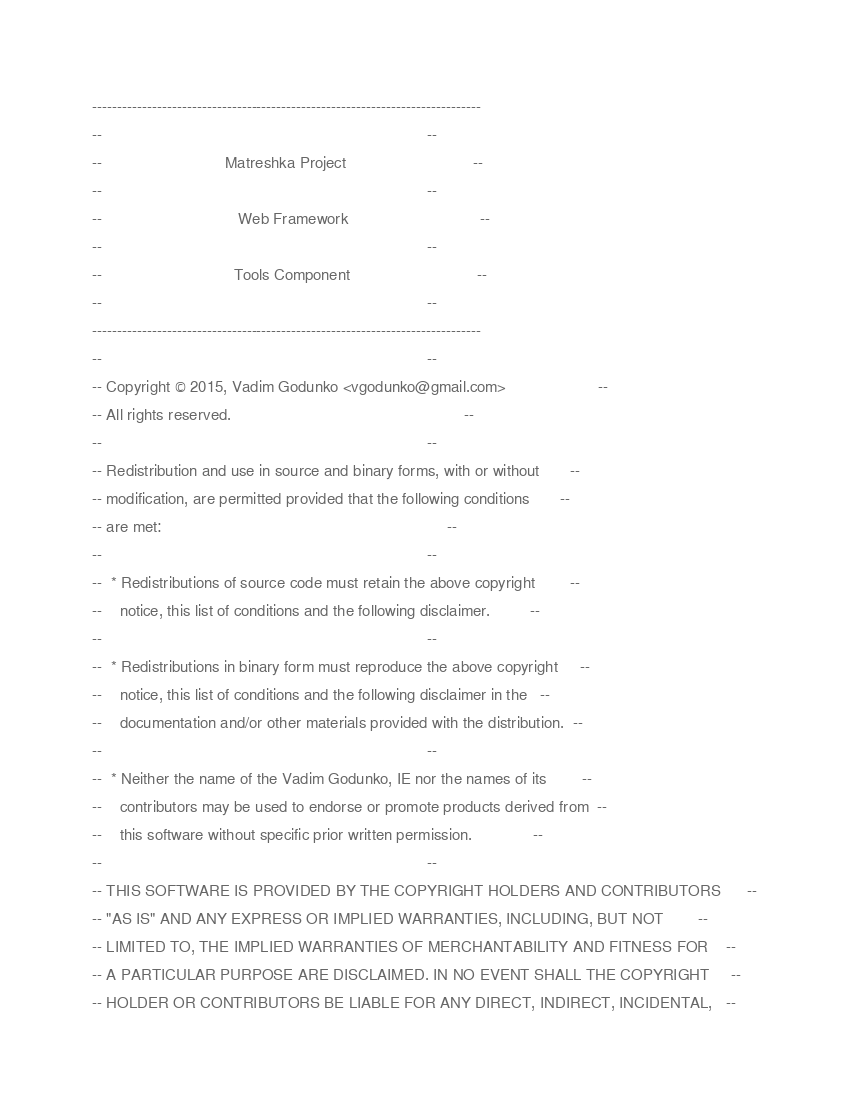Convert code to text. <code><loc_0><loc_0><loc_500><loc_500><_Ada_>------------------------------------------------------------------------------
--                                                                          --
--                            Matreshka Project                             --
--                                                                          --
--                               Web Framework                              --
--                                                                          --
--                              Tools Component                             --
--                                                                          --
------------------------------------------------------------------------------
--                                                                          --
-- Copyright © 2015, Vadim Godunko <vgodunko@gmail.com>                     --
-- All rights reserved.                                                     --
--                                                                          --
-- Redistribution and use in source and binary forms, with or without       --
-- modification, are permitted provided that the following conditions       --
-- are met:                                                                 --
--                                                                          --
--  * Redistributions of source code must retain the above copyright        --
--    notice, this list of conditions and the following disclaimer.         --
--                                                                          --
--  * Redistributions in binary form must reproduce the above copyright     --
--    notice, this list of conditions and the following disclaimer in the   --
--    documentation and/or other materials provided with the distribution.  --
--                                                                          --
--  * Neither the name of the Vadim Godunko, IE nor the names of its        --
--    contributors may be used to endorse or promote products derived from  --
--    this software without specific prior written permission.              --
--                                                                          --
-- THIS SOFTWARE IS PROVIDED BY THE COPYRIGHT HOLDERS AND CONTRIBUTORS      --
-- "AS IS" AND ANY EXPRESS OR IMPLIED WARRANTIES, INCLUDING, BUT NOT        --
-- LIMITED TO, THE IMPLIED WARRANTIES OF MERCHANTABILITY AND FITNESS FOR    --
-- A PARTICULAR PURPOSE ARE DISCLAIMED. IN NO EVENT SHALL THE COPYRIGHT     --
-- HOLDER OR CONTRIBUTORS BE LIABLE FOR ANY DIRECT, INDIRECT, INCIDENTAL,   --</code> 